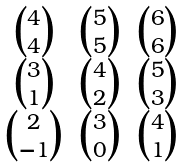<formula> <loc_0><loc_0><loc_500><loc_500>\begin{matrix} 4 \choose 4 & 5 \choose 5 & 6 \choose 6 \\ 3 \choose 1 & 4 \choose 2 & 5 \choose 3 \\ 2 \choose - 1 & 3 \choose 0 & 4 \choose 1 \end{matrix}</formula> 